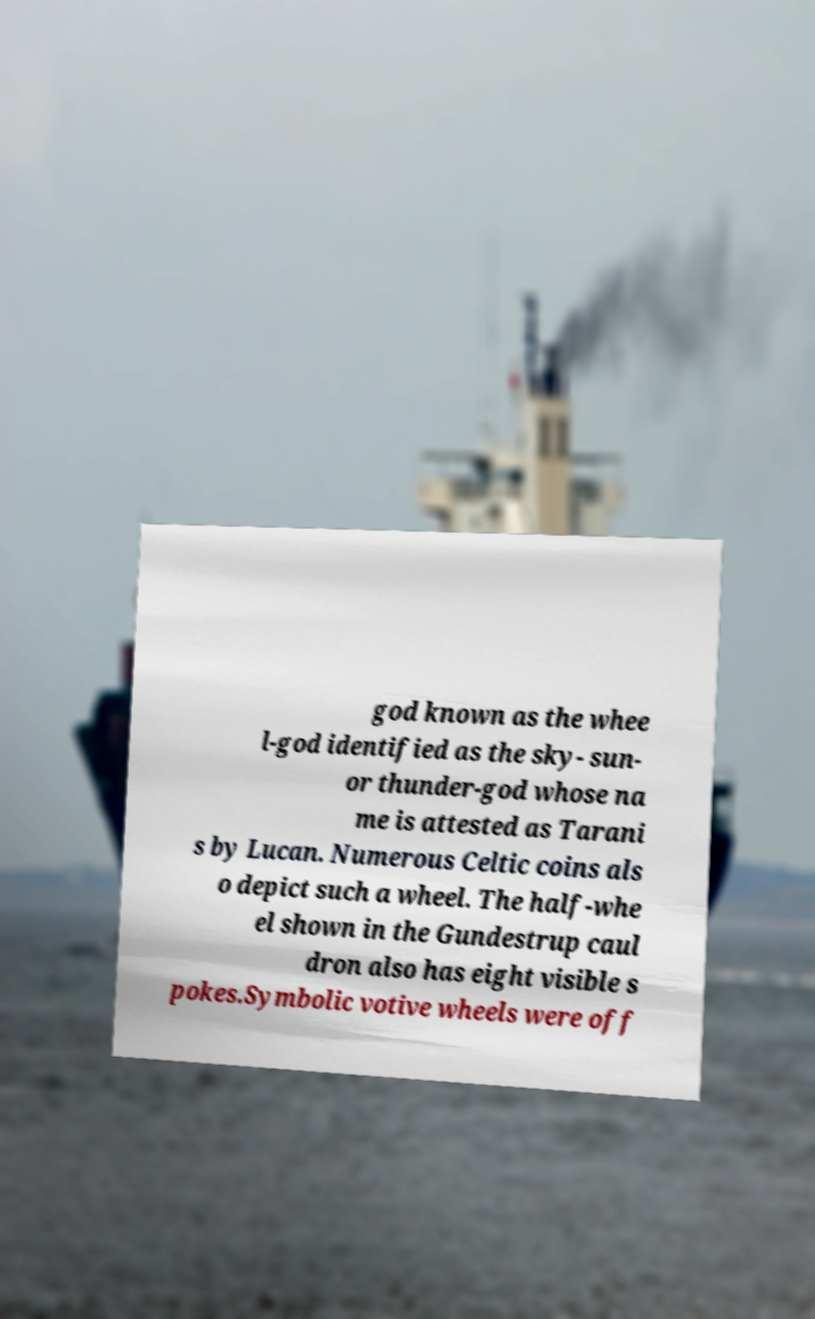Can you accurately transcribe the text from the provided image for me? god known as the whee l-god identified as the sky- sun- or thunder-god whose na me is attested as Tarani s by Lucan. Numerous Celtic coins als o depict such a wheel. The half-whe el shown in the Gundestrup caul dron also has eight visible s pokes.Symbolic votive wheels were off 